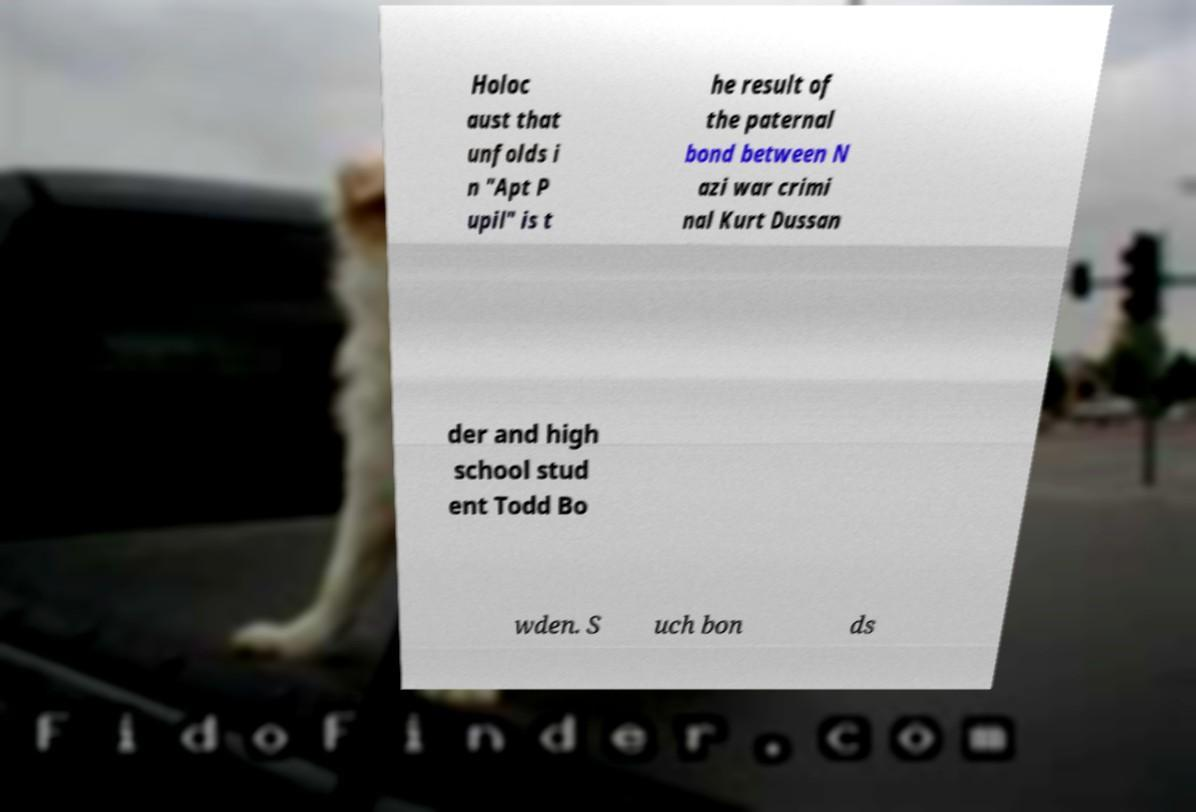Could you assist in decoding the text presented in this image and type it out clearly? Holoc aust that unfolds i n "Apt P upil" is t he result of the paternal bond between N azi war crimi nal Kurt Dussan der and high school stud ent Todd Bo wden. S uch bon ds 